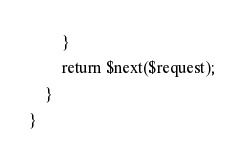Convert code to text. <code><loc_0><loc_0><loc_500><loc_500><_PHP_>
        }   
        return $next($request);  
    }
}

</code> 